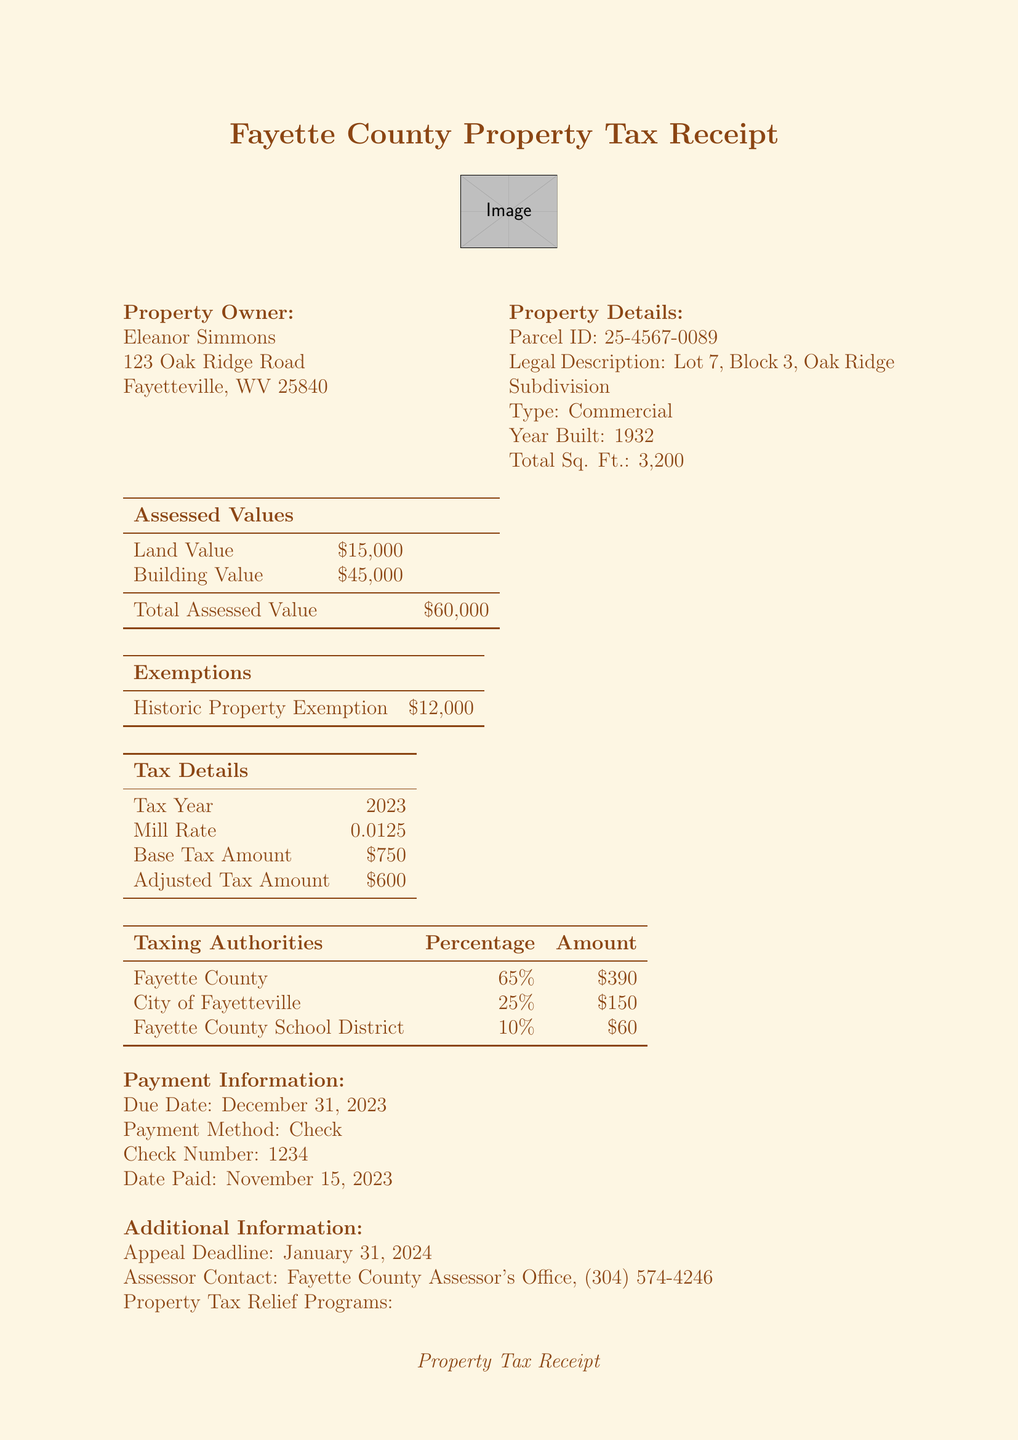What is the name of the property owner? The name of the property owner is specified in the document.
Answer: Eleanor Simmons What is the total assessed value of the property? The total assessed value can be found in the assessed values section.
Answer: $60,000 What is the building value? The building value is part of the assessed values listed in the document.
Answer: $45,000 How much is the historic property exemption? The historic property exemption amount is detailed under exemptions.
Answer: $12,000 What is the adjusted tax amount for 2023? The adjusted tax amount is provided under tax details for the year 2023.
Answer: $600 How many taxing authorities are listed? The number of taxing authorities can be counted in the respective section of the document.
Answer: 3 What is the due date for the payment? The due date is mentioned in the payment information section of the document.
Answer: December 31, 2023 What is the appeal deadline? The appeal deadline is provided under additional information.
Answer: January 31, 2024 What is the mill rate for the tax year? The mill rate can be found in the tax details section of the document.
Answer: 0.0125 